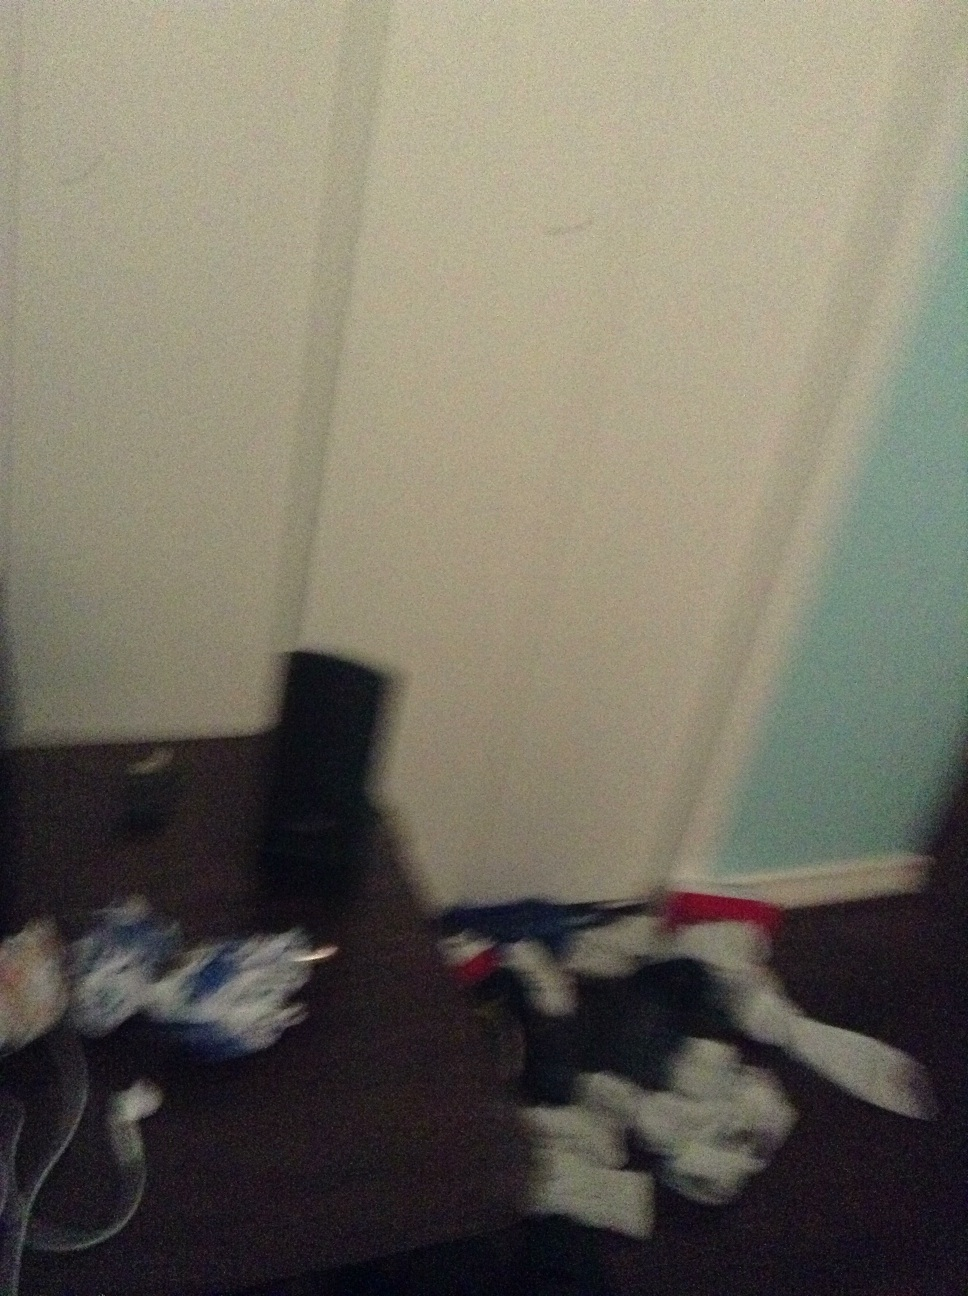Can you describe any items or objects that you can clearly make out in this image? The image shows a variety of items, though it’s somewhat difficult to make out the details because of the image's blurriness. However, there seems to be some electronics like speakers visible, alongside miscellaneous objects possibly including clothing and sheets of paper. 